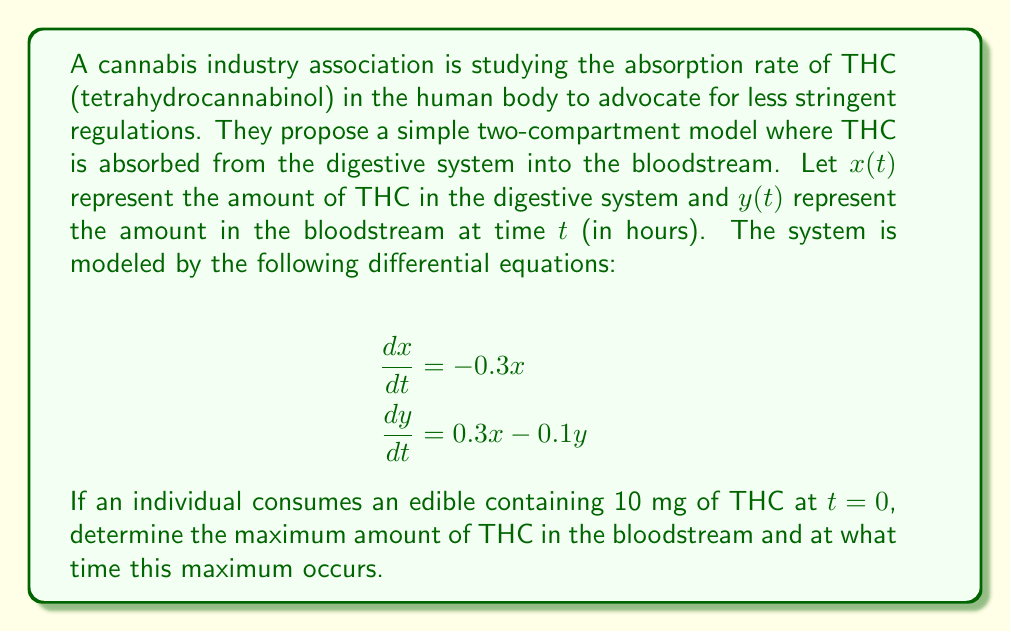Help me with this question. To solve this problem, we need to follow these steps:

1) First, we need to solve the system of differential equations.

2) For $x(t)$, we have a simple first-order differential equation:
   $$\frac{dx}{dt} = -0.3x$$
   The solution to this is:
   $$x(t) = x_0e^{-0.3t}$$
   where $x_0 = 10$ mg (initial amount in the digestive system).

3) Now we can solve for $y(t)$ using the equation:
   $$\frac{dy}{dt} = 0.3x - 0.1y = 0.3(10e^{-0.3t}) - 0.1y$$

4) This is a linear first-order differential equation. The general solution is:
   $$y(t) = ce^{-0.1t} + 15e^{-0.3t}$$
   where $c$ is a constant we need to determine.

5) At $t=0$, $y(0) = 0$ (no THC in bloodstream initially). So:
   $$0 = c + 15$$
   $$c = -15$$

6) Therefore, the complete solution for $y(t)$ is:
   $$y(t) = 15(e^{-0.3t} - e^{-0.1t})$$

7) To find the maximum, we differentiate $y(t)$ and set it to zero:
   $$\frac{dy}{dt} = 15(-0.3e^{-0.3t} + 0.1e^{-0.1t}) = 0$$

8) Solving this equation:
   $$0.3e^{-0.3t} = 0.1e^{-0.1t}$$
   $$3e^{-0.2t} = 1$$
   $$e^{-0.2t} = \frac{1}{3}$$
   $$-0.2t = \ln(\frac{1}{3})$$
   $$t = -5\ln(\frac{1}{3}) \approx 5.49 \text{ hours}$$

9) The maximum amount can be found by plugging this time back into $y(t)$:
   $$y(5.49) = 15(e^{-0.3(5.49)} - e^{-0.1(5.49)}) \approx 3.93 \text{ mg}$$
Answer: The maximum amount of THC in the bloodstream is approximately 3.93 mg, occurring at about 5.49 hours after consumption. 